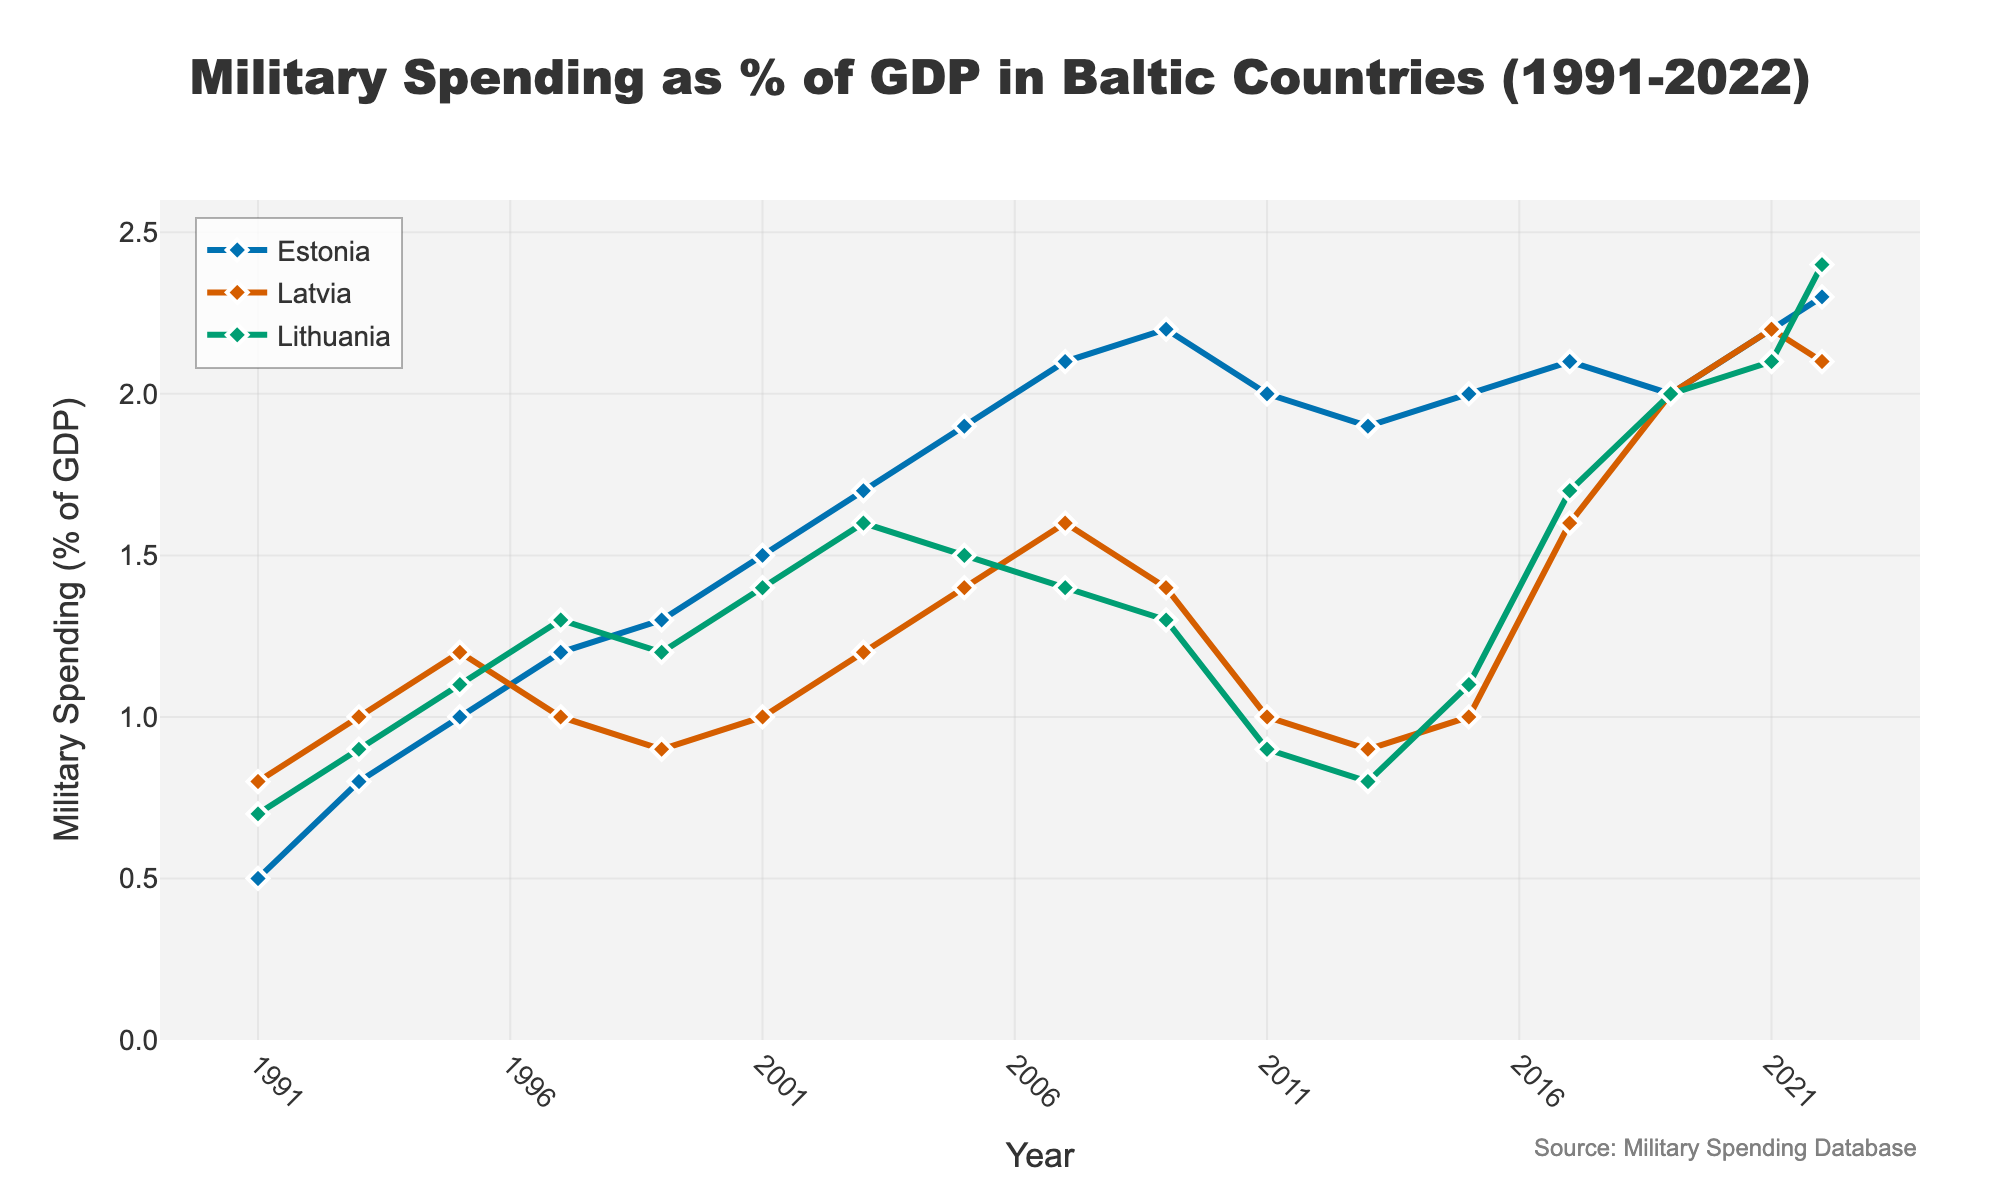What's the trend for Estonia's military spending from 1991 to 2022? Estonia's military spending shows a general upward trend from 1991 to 2022, starting at 0.5% and reaching 2.3% by 2022.
Answer: Upward Which year had the lowest military spending for Lithuania, and what was the percentage? The lowest military spending for Lithuania was in 2013 at 0.8%.
Answer: 2013, 0.8% How did Latvia's military spending change between 2011 and 2013? Between 2011 and 2013, Latvia's military spending decreased from 1.0% to 0.9%.
Answer: Decreased Which country had the highest military spending as a percentage of GDP in 2009? Estonia had the highest military spending in 2009 at 2.2%.
Answer: Estonia What's the difference in military spending between Estonia and Latvia in 2022? In 2022, Estonia's military spending was 2.3% and Latvia's was 2.1%, so the difference is 2.3% - 2.1% = 0.2%.
Answer: 0.2% Compare the military spending trends of Estonia and Lithuania from 2001 to 2011. From 2001 to 2011, Estonia's military spending increased from 1.5% to 2.0%, while Lithuania's fluctuated, ultimately decreasing from 1.4% to 0.9%.
Answer: Estonia increased, Lithuania fluctuated then decreased Which country had the most consistent military spending during the period shown, and why? Latvia had the most consistent military spending, as it shows fewer fluctuations compared to Estonia and Lithuania.
Answer: Latvia In which years did all three countries have similar military spending percentages? In 2019, all three countries had similar military spending percentages at 2.0%.
Answer: 2019 What can be inferred about the overall military spending trends in Baltic countries from 1991 to 2022? Overall, all three Baltic countries show an increasing trend in military spending as a percentage of GDP, with variations.
Answer: Increasing trend 